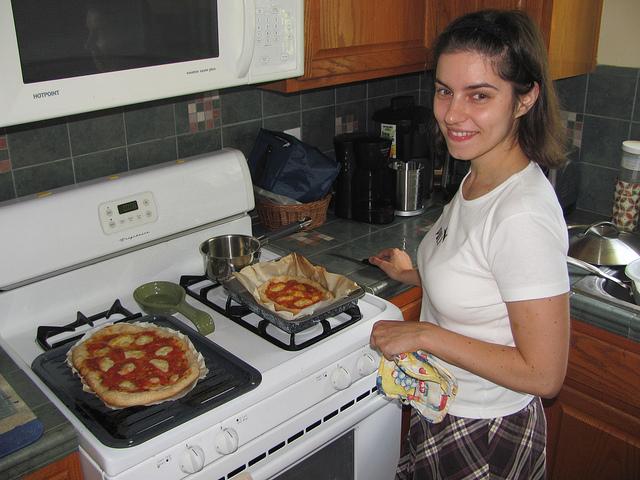Why has the young woman in flannel pants and white shirt smiling in the kitchen near the oven?
Be succinct. Happy. What is the purpose of the green dish?
Quick response, please. Spoon rest. What is the woman cooking?
Concise answer only. Pizza. What appliance is the pizza in?
Give a very brief answer. Stove. What is the woman's name?
Write a very short answer. Lisa. Is that lettuce on the plate?
Give a very brief answer. No. Is this a personal kitchen?
Write a very short answer. Yes. How long until this pizza is done?
Keep it brief. 20 minutes. What appliance is above the stove?
Answer briefly. Microwave. What color are the cupboards?
Quick response, please. Brown. 